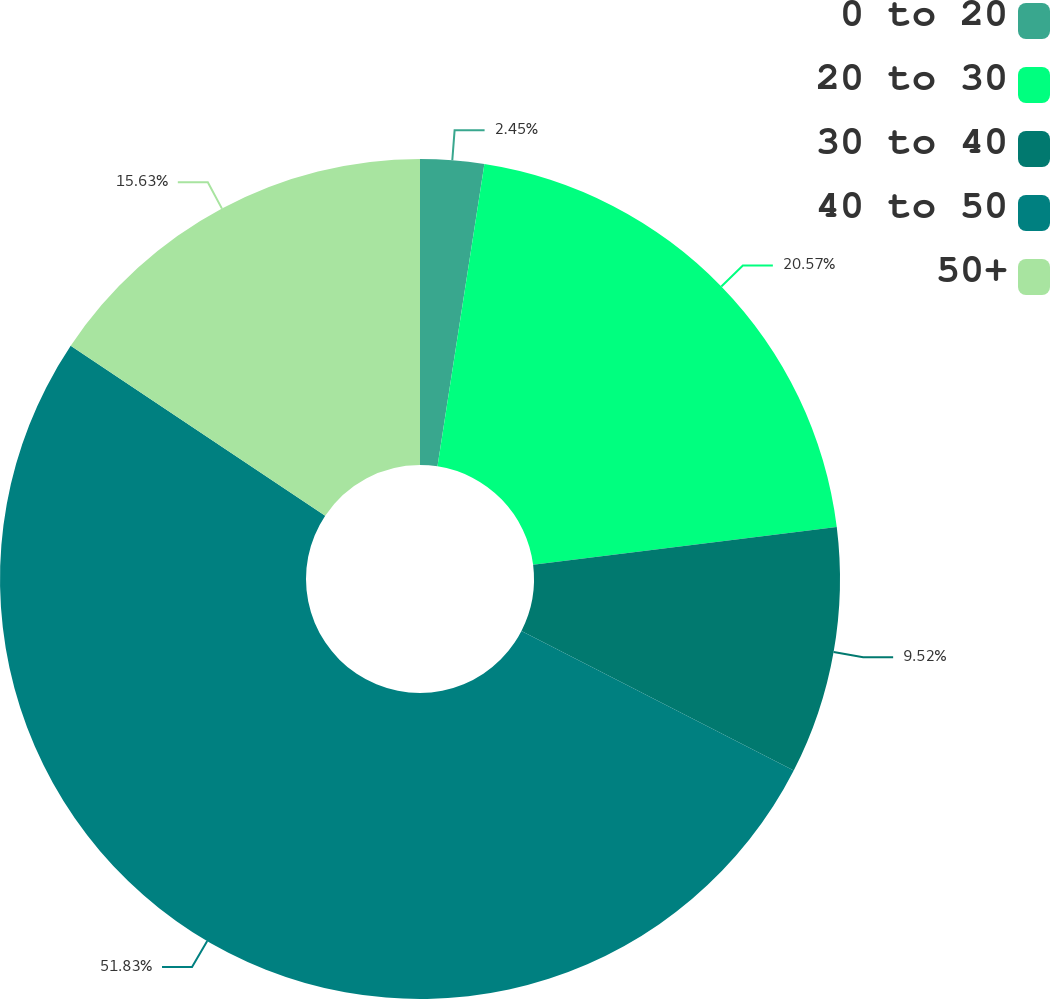Convert chart to OTSL. <chart><loc_0><loc_0><loc_500><loc_500><pie_chart><fcel>0 to 20<fcel>20 to 30<fcel>30 to 40<fcel>40 to 50<fcel>50+<nl><fcel>2.45%<fcel>20.57%<fcel>9.52%<fcel>51.83%<fcel>15.63%<nl></chart> 